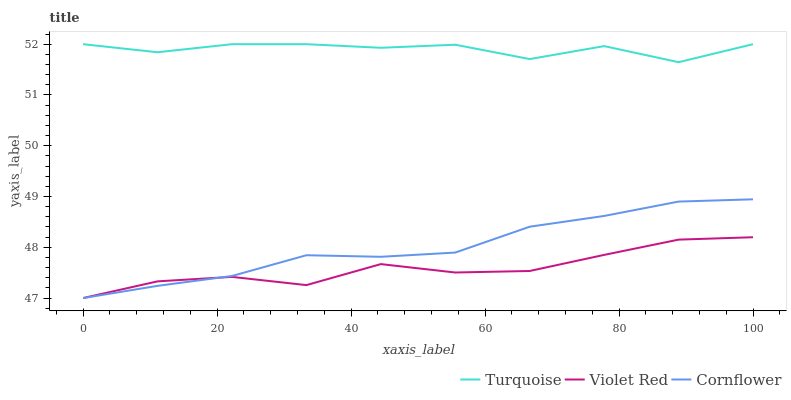Does Violet Red have the minimum area under the curve?
Answer yes or no. Yes. Does Turquoise have the maximum area under the curve?
Answer yes or no. Yes. Does Turquoise have the minimum area under the curve?
Answer yes or no. No. Does Violet Red have the maximum area under the curve?
Answer yes or no. No. Is Cornflower the smoothest?
Answer yes or no. Yes. Is Turquoise the roughest?
Answer yes or no. Yes. Is Violet Red the smoothest?
Answer yes or no. No. Is Violet Red the roughest?
Answer yes or no. No. Does Cornflower have the lowest value?
Answer yes or no. Yes. Does Turquoise have the lowest value?
Answer yes or no. No. Does Turquoise have the highest value?
Answer yes or no. Yes. Does Violet Red have the highest value?
Answer yes or no. No. Is Cornflower less than Turquoise?
Answer yes or no. Yes. Is Turquoise greater than Violet Red?
Answer yes or no. Yes. Does Violet Red intersect Cornflower?
Answer yes or no. Yes. Is Violet Red less than Cornflower?
Answer yes or no. No. Is Violet Red greater than Cornflower?
Answer yes or no. No. Does Cornflower intersect Turquoise?
Answer yes or no. No. 